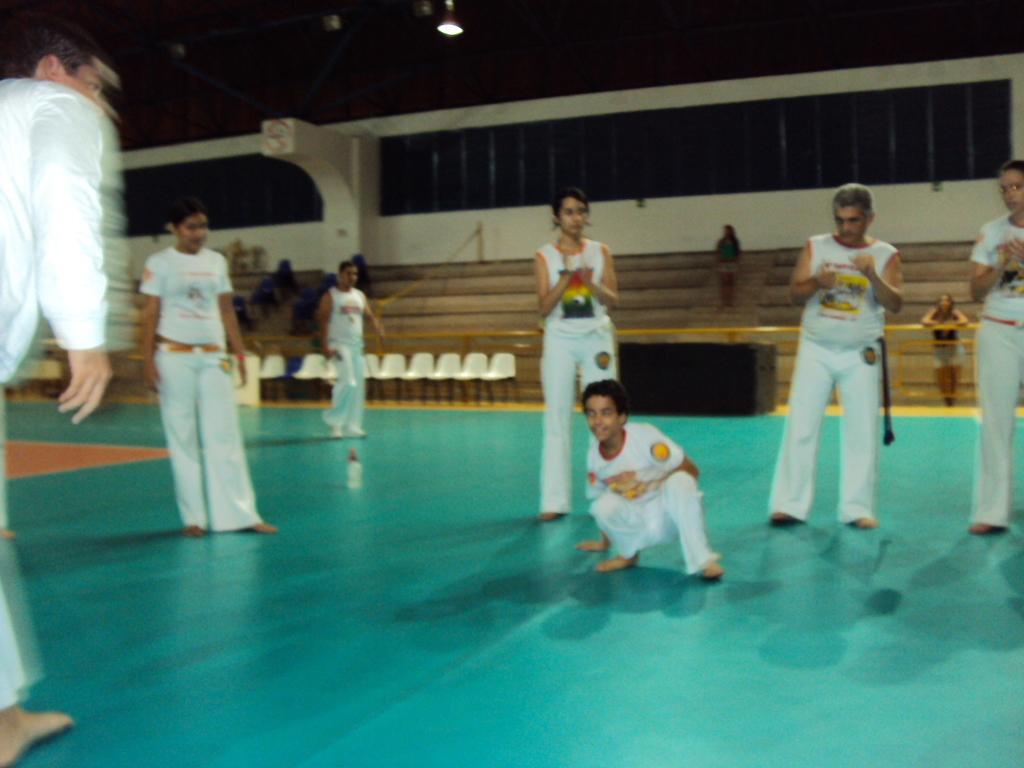How would you summarize this image in a sentence or two? This image consists of many people wearing white dress. At the bottom, there is floor. The floor is in green color. It looks like an indoor stadium. In the front, there are chairs in white color. To the top, there is roof to which lights are hanged. 